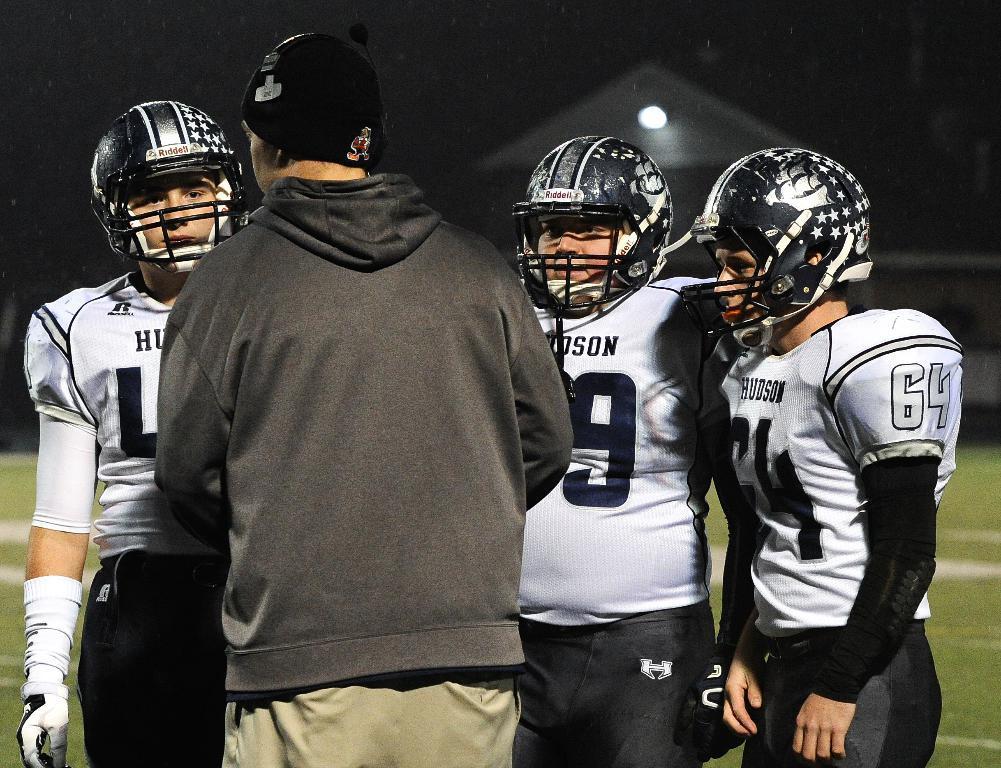How would you summarize this image in a sentence or two? As we can see in the image in the front there are four people. These three are wearing helmets and white color t shirts. There is grass and light. The image is little dark. 